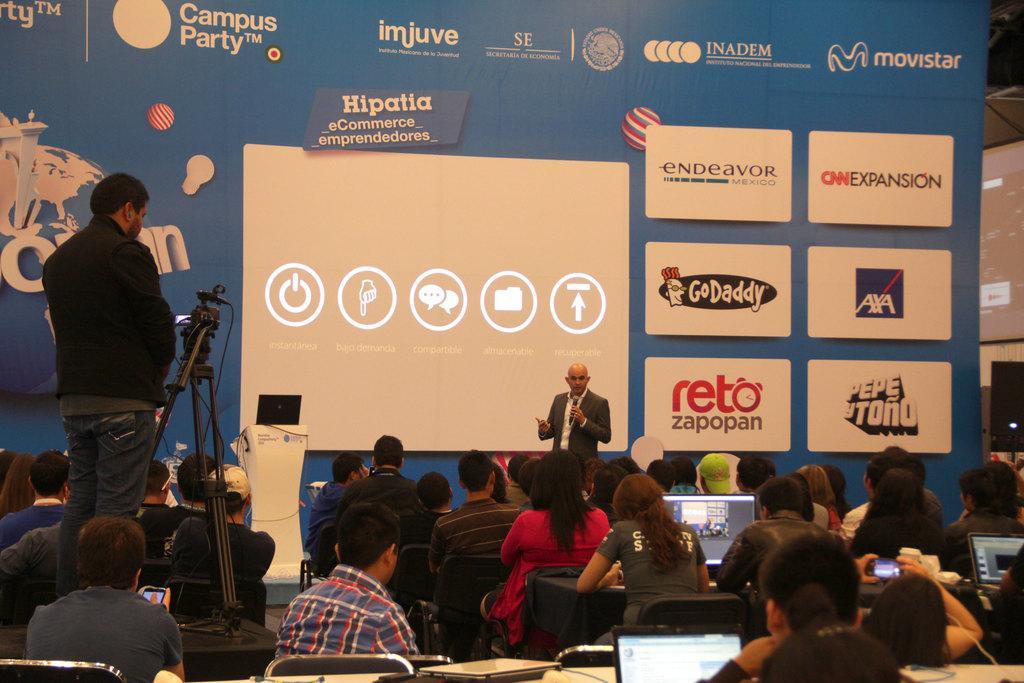How would you summarize this image in a sentence or two? In this picture we can see a group of people and some people are sitting on chairs and some people are standing, here we can see laptops, camera and some objects and in the background we can see a screen, posters and some objects. 